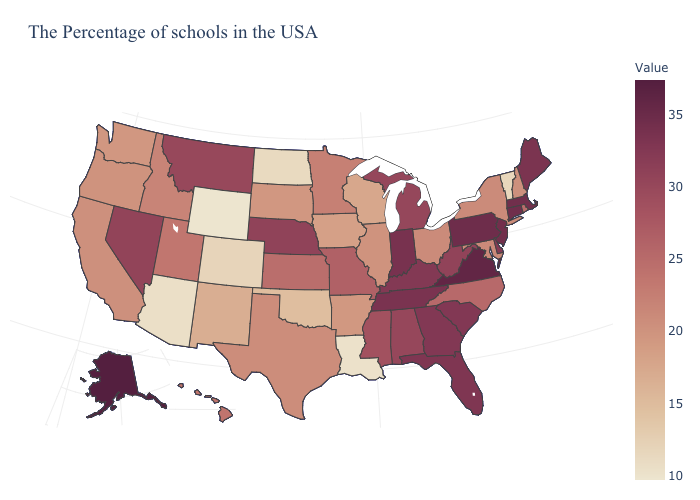Which states have the highest value in the USA?
Give a very brief answer. Alaska. Among the states that border California , does Oregon have the highest value?
Quick response, please. No. Which states have the lowest value in the MidWest?
Quick response, please. North Dakota. Among the states that border Arkansas , does Tennessee have the highest value?
Short answer required. Yes. Does North Dakota have the lowest value in the MidWest?
Quick response, please. Yes. 